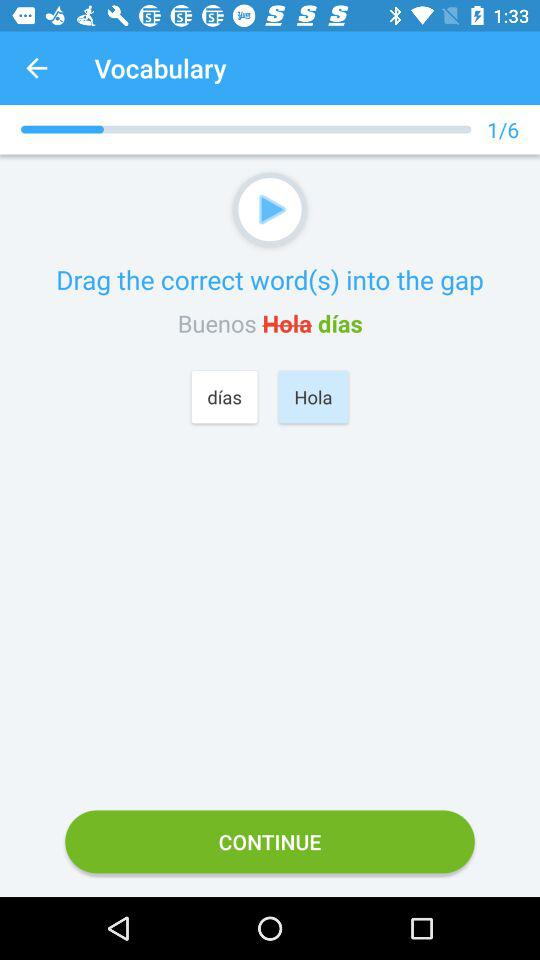How many questions in total are there? There are 6 questions in total. 